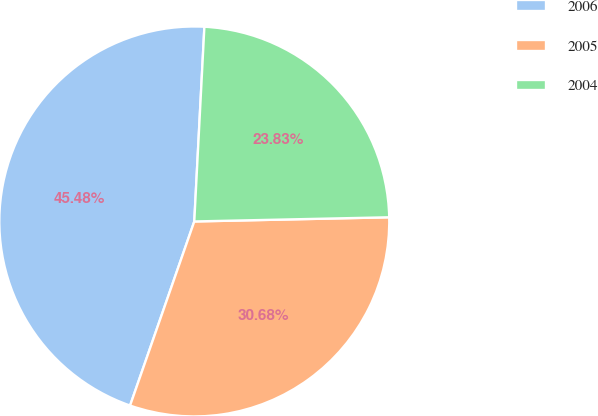Convert chart. <chart><loc_0><loc_0><loc_500><loc_500><pie_chart><fcel>2006<fcel>2005<fcel>2004<nl><fcel>45.48%<fcel>30.68%<fcel>23.83%<nl></chart> 